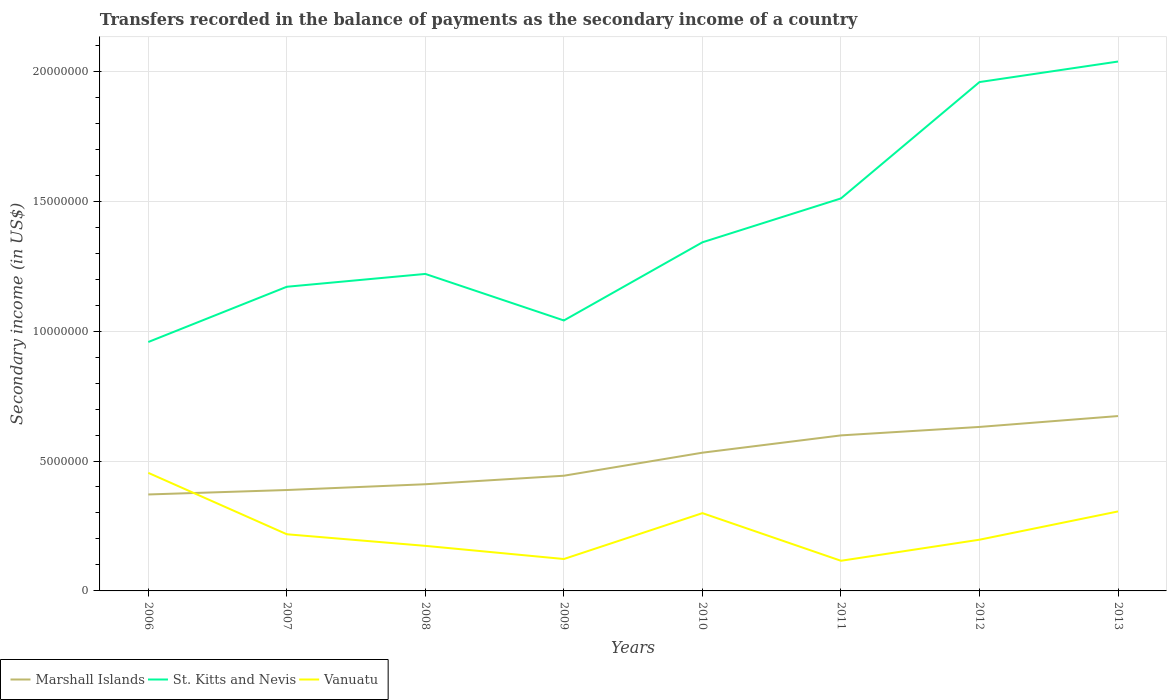How many different coloured lines are there?
Keep it short and to the point. 3. Is the number of lines equal to the number of legend labels?
Offer a terse response. Yes. Across all years, what is the maximum secondary income of in Vanuatu?
Your answer should be very brief. 1.16e+06. In which year was the secondary income of in Marshall Islands maximum?
Make the answer very short. 2006. What is the total secondary income of in Vanuatu in the graph?
Your answer should be very brief. -7.43e+05. What is the difference between the highest and the second highest secondary income of in St. Kitts and Nevis?
Ensure brevity in your answer.  1.08e+07. Is the secondary income of in Marshall Islands strictly greater than the secondary income of in St. Kitts and Nevis over the years?
Make the answer very short. Yes. How many lines are there?
Provide a short and direct response. 3. How many years are there in the graph?
Keep it short and to the point. 8. What is the difference between two consecutive major ticks on the Y-axis?
Give a very brief answer. 5.00e+06. Are the values on the major ticks of Y-axis written in scientific E-notation?
Your response must be concise. No. Does the graph contain grids?
Offer a terse response. Yes. How many legend labels are there?
Your answer should be very brief. 3. How are the legend labels stacked?
Offer a very short reply. Horizontal. What is the title of the graph?
Give a very brief answer. Transfers recorded in the balance of payments as the secondary income of a country. Does "Liechtenstein" appear as one of the legend labels in the graph?
Ensure brevity in your answer.  No. What is the label or title of the Y-axis?
Give a very brief answer. Secondary income (in US$). What is the Secondary income (in US$) in Marshall Islands in 2006?
Offer a terse response. 3.71e+06. What is the Secondary income (in US$) of St. Kitts and Nevis in 2006?
Give a very brief answer. 9.58e+06. What is the Secondary income (in US$) in Vanuatu in 2006?
Keep it short and to the point. 4.54e+06. What is the Secondary income (in US$) of Marshall Islands in 2007?
Provide a succinct answer. 3.88e+06. What is the Secondary income (in US$) in St. Kitts and Nevis in 2007?
Give a very brief answer. 1.17e+07. What is the Secondary income (in US$) of Vanuatu in 2007?
Provide a short and direct response. 2.18e+06. What is the Secondary income (in US$) of Marshall Islands in 2008?
Your answer should be compact. 4.11e+06. What is the Secondary income (in US$) in St. Kitts and Nevis in 2008?
Provide a short and direct response. 1.22e+07. What is the Secondary income (in US$) of Vanuatu in 2008?
Your answer should be compact. 1.73e+06. What is the Secondary income (in US$) in Marshall Islands in 2009?
Provide a short and direct response. 4.43e+06. What is the Secondary income (in US$) of St. Kitts and Nevis in 2009?
Your answer should be compact. 1.04e+07. What is the Secondary income (in US$) in Vanuatu in 2009?
Give a very brief answer. 1.23e+06. What is the Secondary income (in US$) in Marshall Islands in 2010?
Provide a short and direct response. 5.32e+06. What is the Secondary income (in US$) in St. Kitts and Nevis in 2010?
Make the answer very short. 1.34e+07. What is the Secondary income (in US$) in Vanuatu in 2010?
Your answer should be compact. 2.99e+06. What is the Secondary income (in US$) in Marshall Islands in 2011?
Offer a terse response. 5.99e+06. What is the Secondary income (in US$) of St. Kitts and Nevis in 2011?
Keep it short and to the point. 1.51e+07. What is the Secondary income (in US$) in Vanuatu in 2011?
Provide a succinct answer. 1.16e+06. What is the Secondary income (in US$) in Marshall Islands in 2012?
Offer a very short reply. 6.31e+06. What is the Secondary income (in US$) of St. Kitts and Nevis in 2012?
Keep it short and to the point. 1.96e+07. What is the Secondary income (in US$) of Vanuatu in 2012?
Offer a terse response. 1.97e+06. What is the Secondary income (in US$) of Marshall Islands in 2013?
Give a very brief answer. 6.73e+06. What is the Secondary income (in US$) of St. Kitts and Nevis in 2013?
Keep it short and to the point. 2.04e+07. What is the Secondary income (in US$) of Vanuatu in 2013?
Offer a very short reply. 3.06e+06. Across all years, what is the maximum Secondary income (in US$) in Marshall Islands?
Give a very brief answer. 6.73e+06. Across all years, what is the maximum Secondary income (in US$) of St. Kitts and Nevis?
Your response must be concise. 2.04e+07. Across all years, what is the maximum Secondary income (in US$) of Vanuatu?
Offer a terse response. 4.54e+06. Across all years, what is the minimum Secondary income (in US$) in Marshall Islands?
Your response must be concise. 3.71e+06. Across all years, what is the minimum Secondary income (in US$) in St. Kitts and Nevis?
Offer a very short reply. 9.58e+06. Across all years, what is the minimum Secondary income (in US$) of Vanuatu?
Provide a short and direct response. 1.16e+06. What is the total Secondary income (in US$) of Marshall Islands in the graph?
Make the answer very short. 4.05e+07. What is the total Secondary income (in US$) in St. Kitts and Nevis in the graph?
Your answer should be compact. 1.12e+08. What is the total Secondary income (in US$) of Vanuatu in the graph?
Ensure brevity in your answer.  1.89e+07. What is the difference between the Secondary income (in US$) of Marshall Islands in 2006 and that in 2007?
Your answer should be compact. -1.71e+05. What is the difference between the Secondary income (in US$) of St. Kitts and Nevis in 2006 and that in 2007?
Your answer should be compact. -2.13e+06. What is the difference between the Secondary income (in US$) of Vanuatu in 2006 and that in 2007?
Make the answer very short. 2.36e+06. What is the difference between the Secondary income (in US$) of Marshall Islands in 2006 and that in 2008?
Make the answer very short. -3.94e+05. What is the difference between the Secondary income (in US$) in St. Kitts and Nevis in 2006 and that in 2008?
Your answer should be compact. -2.62e+06. What is the difference between the Secondary income (in US$) in Vanuatu in 2006 and that in 2008?
Ensure brevity in your answer.  2.81e+06. What is the difference between the Secondary income (in US$) in Marshall Islands in 2006 and that in 2009?
Make the answer very short. -7.22e+05. What is the difference between the Secondary income (in US$) of St. Kitts and Nevis in 2006 and that in 2009?
Offer a very short reply. -8.29e+05. What is the difference between the Secondary income (in US$) of Vanuatu in 2006 and that in 2009?
Provide a succinct answer. 3.32e+06. What is the difference between the Secondary income (in US$) in Marshall Islands in 2006 and that in 2010?
Your answer should be compact. -1.61e+06. What is the difference between the Secondary income (in US$) in St. Kitts and Nevis in 2006 and that in 2010?
Make the answer very short. -3.84e+06. What is the difference between the Secondary income (in US$) of Vanuatu in 2006 and that in 2010?
Your answer should be very brief. 1.55e+06. What is the difference between the Secondary income (in US$) in Marshall Islands in 2006 and that in 2011?
Keep it short and to the point. -2.27e+06. What is the difference between the Secondary income (in US$) in St. Kitts and Nevis in 2006 and that in 2011?
Keep it short and to the point. -5.53e+06. What is the difference between the Secondary income (in US$) of Vanuatu in 2006 and that in 2011?
Your answer should be very brief. 3.38e+06. What is the difference between the Secondary income (in US$) of Marshall Islands in 2006 and that in 2012?
Provide a succinct answer. -2.60e+06. What is the difference between the Secondary income (in US$) in St. Kitts and Nevis in 2006 and that in 2012?
Your answer should be compact. -1.00e+07. What is the difference between the Secondary income (in US$) in Vanuatu in 2006 and that in 2012?
Your answer should be compact. 2.57e+06. What is the difference between the Secondary income (in US$) of Marshall Islands in 2006 and that in 2013?
Provide a succinct answer. -3.02e+06. What is the difference between the Secondary income (in US$) of St. Kitts and Nevis in 2006 and that in 2013?
Your answer should be compact. -1.08e+07. What is the difference between the Secondary income (in US$) of Vanuatu in 2006 and that in 2013?
Ensure brevity in your answer.  1.48e+06. What is the difference between the Secondary income (in US$) in Marshall Islands in 2007 and that in 2008?
Offer a terse response. -2.22e+05. What is the difference between the Secondary income (in US$) in St. Kitts and Nevis in 2007 and that in 2008?
Offer a terse response. -4.94e+05. What is the difference between the Secondary income (in US$) in Vanuatu in 2007 and that in 2008?
Your answer should be very brief. 4.47e+05. What is the difference between the Secondary income (in US$) of Marshall Islands in 2007 and that in 2009?
Offer a terse response. -5.51e+05. What is the difference between the Secondary income (in US$) of St. Kitts and Nevis in 2007 and that in 2009?
Your answer should be compact. 1.30e+06. What is the difference between the Secondary income (in US$) in Vanuatu in 2007 and that in 2009?
Give a very brief answer. 9.52e+05. What is the difference between the Secondary income (in US$) of Marshall Islands in 2007 and that in 2010?
Offer a terse response. -1.44e+06. What is the difference between the Secondary income (in US$) in St. Kitts and Nevis in 2007 and that in 2010?
Your answer should be very brief. -1.71e+06. What is the difference between the Secondary income (in US$) in Vanuatu in 2007 and that in 2010?
Offer a terse response. -8.13e+05. What is the difference between the Secondary income (in US$) in Marshall Islands in 2007 and that in 2011?
Your response must be concise. -2.10e+06. What is the difference between the Secondary income (in US$) in St. Kitts and Nevis in 2007 and that in 2011?
Give a very brief answer. -3.40e+06. What is the difference between the Secondary income (in US$) of Vanuatu in 2007 and that in 2011?
Your response must be concise. 1.02e+06. What is the difference between the Secondary income (in US$) of Marshall Islands in 2007 and that in 2012?
Ensure brevity in your answer.  -2.43e+06. What is the difference between the Secondary income (in US$) of St. Kitts and Nevis in 2007 and that in 2012?
Provide a succinct answer. -7.88e+06. What is the difference between the Secondary income (in US$) of Vanuatu in 2007 and that in 2012?
Keep it short and to the point. 2.10e+05. What is the difference between the Secondary income (in US$) in Marshall Islands in 2007 and that in 2013?
Provide a succinct answer. -2.85e+06. What is the difference between the Secondary income (in US$) of St. Kitts and Nevis in 2007 and that in 2013?
Offer a very short reply. -8.67e+06. What is the difference between the Secondary income (in US$) in Vanuatu in 2007 and that in 2013?
Provide a succinct answer. -8.79e+05. What is the difference between the Secondary income (in US$) of Marshall Islands in 2008 and that in 2009?
Give a very brief answer. -3.28e+05. What is the difference between the Secondary income (in US$) in St. Kitts and Nevis in 2008 and that in 2009?
Keep it short and to the point. 1.79e+06. What is the difference between the Secondary income (in US$) in Vanuatu in 2008 and that in 2009?
Give a very brief answer. 5.06e+05. What is the difference between the Secondary income (in US$) of Marshall Islands in 2008 and that in 2010?
Offer a terse response. -1.21e+06. What is the difference between the Secondary income (in US$) of St. Kitts and Nevis in 2008 and that in 2010?
Provide a short and direct response. -1.22e+06. What is the difference between the Secondary income (in US$) of Vanuatu in 2008 and that in 2010?
Your answer should be very brief. -1.26e+06. What is the difference between the Secondary income (in US$) of Marshall Islands in 2008 and that in 2011?
Your response must be concise. -1.88e+06. What is the difference between the Secondary income (in US$) in St. Kitts and Nevis in 2008 and that in 2011?
Ensure brevity in your answer.  -2.91e+06. What is the difference between the Secondary income (in US$) in Vanuatu in 2008 and that in 2011?
Offer a very short reply. 5.74e+05. What is the difference between the Secondary income (in US$) in Marshall Islands in 2008 and that in 2012?
Offer a very short reply. -2.21e+06. What is the difference between the Secondary income (in US$) in St. Kitts and Nevis in 2008 and that in 2012?
Provide a short and direct response. -7.38e+06. What is the difference between the Secondary income (in US$) in Vanuatu in 2008 and that in 2012?
Provide a short and direct response. -2.37e+05. What is the difference between the Secondary income (in US$) of Marshall Islands in 2008 and that in 2013?
Offer a terse response. -2.62e+06. What is the difference between the Secondary income (in US$) of St. Kitts and Nevis in 2008 and that in 2013?
Offer a very short reply. -8.17e+06. What is the difference between the Secondary income (in US$) of Vanuatu in 2008 and that in 2013?
Provide a succinct answer. -1.33e+06. What is the difference between the Secondary income (in US$) of Marshall Islands in 2009 and that in 2010?
Offer a terse response. -8.86e+05. What is the difference between the Secondary income (in US$) in St. Kitts and Nevis in 2009 and that in 2010?
Provide a short and direct response. -3.01e+06. What is the difference between the Secondary income (in US$) of Vanuatu in 2009 and that in 2010?
Your response must be concise. -1.77e+06. What is the difference between the Secondary income (in US$) of Marshall Islands in 2009 and that in 2011?
Make the answer very short. -1.55e+06. What is the difference between the Secondary income (in US$) of St. Kitts and Nevis in 2009 and that in 2011?
Offer a terse response. -4.70e+06. What is the difference between the Secondary income (in US$) in Vanuatu in 2009 and that in 2011?
Provide a succinct answer. 6.81e+04. What is the difference between the Secondary income (in US$) of Marshall Islands in 2009 and that in 2012?
Make the answer very short. -1.88e+06. What is the difference between the Secondary income (in US$) in St. Kitts and Nevis in 2009 and that in 2012?
Make the answer very short. -9.18e+06. What is the difference between the Secondary income (in US$) in Vanuatu in 2009 and that in 2012?
Provide a short and direct response. -7.43e+05. What is the difference between the Secondary income (in US$) in Marshall Islands in 2009 and that in 2013?
Ensure brevity in your answer.  -2.30e+06. What is the difference between the Secondary income (in US$) in St. Kitts and Nevis in 2009 and that in 2013?
Make the answer very short. -9.97e+06. What is the difference between the Secondary income (in US$) of Vanuatu in 2009 and that in 2013?
Offer a very short reply. -1.83e+06. What is the difference between the Secondary income (in US$) in Marshall Islands in 2010 and that in 2011?
Your answer should be compact. -6.65e+05. What is the difference between the Secondary income (in US$) in St. Kitts and Nevis in 2010 and that in 2011?
Offer a very short reply. -1.69e+06. What is the difference between the Secondary income (in US$) in Vanuatu in 2010 and that in 2011?
Offer a terse response. 1.83e+06. What is the difference between the Secondary income (in US$) of Marshall Islands in 2010 and that in 2012?
Your answer should be very brief. -9.91e+05. What is the difference between the Secondary income (in US$) of St. Kitts and Nevis in 2010 and that in 2012?
Your response must be concise. -6.17e+06. What is the difference between the Secondary income (in US$) in Vanuatu in 2010 and that in 2012?
Your answer should be compact. 1.02e+06. What is the difference between the Secondary income (in US$) of Marshall Islands in 2010 and that in 2013?
Provide a succinct answer. -1.41e+06. What is the difference between the Secondary income (in US$) in St. Kitts and Nevis in 2010 and that in 2013?
Your answer should be very brief. -6.96e+06. What is the difference between the Secondary income (in US$) in Vanuatu in 2010 and that in 2013?
Your answer should be compact. -6.57e+04. What is the difference between the Secondary income (in US$) of Marshall Islands in 2011 and that in 2012?
Ensure brevity in your answer.  -3.26e+05. What is the difference between the Secondary income (in US$) of St. Kitts and Nevis in 2011 and that in 2012?
Give a very brief answer. -4.48e+06. What is the difference between the Secondary income (in US$) of Vanuatu in 2011 and that in 2012?
Ensure brevity in your answer.  -8.11e+05. What is the difference between the Secondary income (in US$) of Marshall Islands in 2011 and that in 2013?
Your response must be concise. -7.44e+05. What is the difference between the Secondary income (in US$) in St. Kitts and Nevis in 2011 and that in 2013?
Your answer should be compact. -5.27e+06. What is the difference between the Secondary income (in US$) of Vanuatu in 2011 and that in 2013?
Provide a short and direct response. -1.90e+06. What is the difference between the Secondary income (in US$) of Marshall Islands in 2012 and that in 2013?
Provide a succinct answer. -4.19e+05. What is the difference between the Secondary income (in US$) of St. Kitts and Nevis in 2012 and that in 2013?
Give a very brief answer. -7.90e+05. What is the difference between the Secondary income (in US$) of Vanuatu in 2012 and that in 2013?
Keep it short and to the point. -1.09e+06. What is the difference between the Secondary income (in US$) of Marshall Islands in 2006 and the Secondary income (in US$) of St. Kitts and Nevis in 2007?
Your answer should be very brief. -7.99e+06. What is the difference between the Secondary income (in US$) of Marshall Islands in 2006 and the Secondary income (in US$) of Vanuatu in 2007?
Your answer should be very brief. 1.53e+06. What is the difference between the Secondary income (in US$) of St. Kitts and Nevis in 2006 and the Secondary income (in US$) of Vanuatu in 2007?
Offer a very short reply. 7.40e+06. What is the difference between the Secondary income (in US$) of Marshall Islands in 2006 and the Secondary income (in US$) of St. Kitts and Nevis in 2008?
Ensure brevity in your answer.  -8.49e+06. What is the difference between the Secondary income (in US$) in Marshall Islands in 2006 and the Secondary income (in US$) in Vanuatu in 2008?
Ensure brevity in your answer.  1.98e+06. What is the difference between the Secondary income (in US$) of St. Kitts and Nevis in 2006 and the Secondary income (in US$) of Vanuatu in 2008?
Keep it short and to the point. 7.85e+06. What is the difference between the Secondary income (in US$) in Marshall Islands in 2006 and the Secondary income (in US$) in St. Kitts and Nevis in 2009?
Give a very brief answer. -6.70e+06. What is the difference between the Secondary income (in US$) in Marshall Islands in 2006 and the Secondary income (in US$) in Vanuatu in 2009?
Provide a succinct answer. 2.48e+06. What is the difference between the Secondary income (in US$) in St. Kitts and Nevis in 2006 and the Secondary income (in US$) in Vanuatu in 2009?
Your answer should be very brief. 8.35e+06. What is the difference between the Secondary income (in US$) in Marshall Islands in 2006 and the Secondary income (in US$) in St. Kitts and Nevis in 2010?
Your answer should be very brief. -9.71e+06. What is the difference between the Secondary income (in US$) of Marshall Islands in 2006 and the Secondary income (in US$) of Vanuatu in 2010?
Provide a short and direct response. 7.18e+05. What is the difference between the Secondary income (in US$) of St. Kitts and Nevis in 2006 and the Secondary income (in US$) of Vanuatu in 2010?
Make the answer very short. 6.59e+06. What is the difference between the Secondary income (in US$) of Marshall Islands in 2006 and the Secondary income (in US$) of St. Kitts and Nevis in 2011?
Provide a short and direct response. -1.14e+07. What is the difference between the Secondary income (in US$) of Marshall Islands in 2006 and the Secondary income (in US$) of Vanuatu in 2011?
Your answer should be very brief. 2.55e+06. What is the difference between the Secondary income (in US$) of St. Kitts and Nevis in 2006 and the Secondary income (in US$) of Vanuatu in 2011?
Provide a succinct answer. 8.42e+06. What is the difference between the Secondary income (in US$) in Marshall Islands in 2006 and the Secondary income (in US$) in St. Kitts and Nevis in 2012?
Provide a succinct answer. -1.59e+07. What is the difference between the Secondary income (in US$) of Marshall Islands in 2006 and the Secondary income (in US$) of Vanuatu in 2012?
Keep it short and to the point. 1.74e+06. What is the difference between the Secondary income (in US$) of St. Kitts and Nevis in 2006 and the Secondary income (in US$) of Vanuatu in 2012?
Provide a succinct answer. 7.61e+06. What is the difference between the Secondary income (in US$) of Marshall Islands in 2006 and the Secondary income (in US$) of St. Kitts and Nevis in 2013?
Offer a very short reply. -1.67e+07. What is the difference between the Secondary income (in US$) of Marshall Islands in 2006 and the Secondary income (in US$) of Vanuatu in 2013?
Your answer should be compact. 6.53e+05. What is the difference between the Secondary income (in US$) in St. Kitts and Nevis in 2006 and the Secondary income (in US$) in Vanuatu in 2013?
Your answer should be very brief. 6.52e+06. What is the difference between the Secondary income (in US$) of Marshall Islands in 2007 and the Secondary income (in US$) of St. Kitts and Nevis in 2008?
Offer a very short reply. -8.32e+06. What is the difference between the Secondary income (in US$) in Marshall Islands in 2007 and the Secondary income (in US$) in Vanuatu in 2008?
Give a very brief answer. 2.15e+06. What is the difference between the Secondary income (in US$) in St. Kitts and Nevis in 2007 and the Secondary income (in US$) in Vanuatu in 2008?
Keep it short and to the point. 9.97e+06. What is the difference between the Secondary income (in US$) in Marshall Islands in 2007 and the Secondary income (in US$) in St. Kitts and Nevis in 2009?
Your answer should be compact. -6.53e+06. What is the difference between the Secondary income (in US$) in Marshall Islands in 2007 and the Secondary income (in US$) in Vanuatu in 2009?
Offer a very short reply. 2.65e+06. What is the difference between the Secondary income (in US$) in St. Kitts and Nevis in 2007 and the Secondary income (in US$) in Vanuatu in 2009?
Offer a terse response. 1.05e+07. What is the difference between the Secondary income (in US$) of Marshall Islands in 2007 and the Secondary income (in US$) of St. Kitts and Nevis in 2010?
Provide a succinct answer. -9.53e+06. What is the difference between the Secondary income (in US$) in Marshall Islands in 2007 and the Secondary income (in US$) in Vanuatu in 2010?
Provide a short and direct response. 8.90e+05. What is the difference between the Secondary income (in US$) in St. Kitts and Nevis in 2007 and the Secondary income (in US$) in Vanuatu in 2010?
Provide a short and direct response. 8.71e+06. What is the difference between the Secondary income (in US$) of Marshall Islands in 2007 and the Secondary income (in US$) of St. Kitts and Nevis in 2011?
Offer a very short reply. -1.12e+07. What is the difference between the Secondary income (in US$) in Marshall Islands in 2007 and the Secondary income (in US$) in Vanuatu in 2011?
Make the answer very short. 2.72e+06. What is the difference between the Secondary income (in US$) of St. Kitts and Nevis in 2007 and the Secondary income (in US$) of Vanuatu in 2011?
Provide a succinct answer. 1.05e+07. What is the difference between the Secondary income (in US$) in Marshall Islands in 2007 and the Secondary income (in US$) in St. Kitts and Nevis in 2012?
Provide a succinct answer. -1.57e+07. What is the difference between the Secondary income (in US$) of Marshall Islands in 2007 and the Secondary income (in US$) of Vanuatu in 2012?
Your response must be concise. 1.91e+06. What is the difference between the Secondary income (in US$) of St. Kitts and Nevis in 2007 and the Secondary income (in US$) of Vanuatu in 2012?
Your answer should be very brief. 9.74e+06. What is the difference between the Secondary income (in US$) of Marshall Islands in 2007 and the Secondary income (in US$) of St. Kitts and Nevis in 2013?
Keep it short and to the point. -1.65e+07. What is the difference between the Secondary income (in US$) of Marshall Islands in 2007 and the Secondary income (in US$) of Vanuatu in 2013?
Make the answer very short. 8.24e+05. What is the difference between the Secondary income (in US$) in St. Kitts and Nevis in 2007 and the Secondary income (in US$) in Vanuatu in 2013?
Offer a very short reply. 8.65e+06. What is the difference between the Secondary income (in US$) in Marshall Islands in 2008 and the Secondary income (in US$) in St. Kitts and Nevis in 2009?
Ensure brevity in your answer.  -6.30e+06. What is the difference between the Secondary income (in US$) of Marshall Islands in 2008 and the Secondary income (in US$) of Vanuatu in 2009?
Your answer should be very brief. 2.88e+06. What is the difference between the Secondary income (in US$) of St. Kitts and Nevis in 2008 and the Secondary income (in US$) of Vanuatu in 2009?
Your answer should be compact. 1.10e+07. What is the difference between the Secondary income (in US$) of Marshall Islands in 2008 and the Secondary income (in US$) of St. Kitts and Nevis in 2010?
Provide a short and direct response. -9.31e+06. What is the difference between the Secondary income (in US$) of Marshall Islands in 2008 and the Secondary income (in US$) of Vanuatu in 2010?
Your response must be concise. 1.11e+06. What is the difference between the Secondary income (in US$) in St. Kitts and Nevis in 2008 and the Secondary income (in US$) in Vanuatu in 2010?
Keep it short and to the point. 9.21e+06. What is the difference between the Secondary income (in US$) in Marshall Islands in 2008 and the Secondary income (in US$) in St. Kitts and Nevis in 2011?
Offer a terse response. -1.10e+07. What is the difference between the Secondary income (in US$) of Marshall Islands in 2008 and the Secondary income (in US$) of Vanuatu in 2011?
Your answer should be compact. 2.95e+06. What is the difference between the Secondary income (in US$) in St. Kitts and Nevis in 2008 and the Secondary income (in US$) in Vanuatu in 2011?
Ensure brevity in your answer.  1.10e+07. What is the difference between the Secondary income (in US$) in Marshall Islands in 2008 and the Secondary income (in US$) in St. Kitts and Nevis in 2012?
Your response must be concise. -1.55e+07. What is the difference between the Secondary income (in US$) in Marshall Islands in 2008 and the Secondary income (in US$) in Vanuatu in 2012?
Provide a short and direct response. 2.13e+06. What is the difference between the Secondary income (in US$) of St. Kitts and Nevis in 2008 and the Secondary income (in US$) of Vanuatu in 2012?
Keep it short and to the point. 1.02e+07. What is the difference between the Secondary income (in US$) of Marshall Islands in 2008 and the Secondary income (in US$) of St. Kitts and Nevis in 2013?
Your answer should be very brief. -1.63e+07. What is the difference between the Secondary income (in US$) of Marshall Islands in 2008 and the Secondary income (in US$) of Vanuatu in 2013?
Your response must be concise. 1.05e+06. What is the difference between the Secondary income (in US$) of St. Kitts and Nevis in 2008 and the Secondary income (in US$) of Vanuatu in 2013?
Provide a short and direct response. 9.14e+06. What is the difference between the Secondary income (in US$) in Marshall Islands in 2009 and the Secondary income (in US$) in St. Kitts and Nevis in 2010?
Your answer should be compact. -8.98e+06. What is the difference between the Secondary income (in US$) of Marshall Islands in 2009 and the Secondary income (in US$) of Vanuatu in 2010?
Keep it short and to the point. 1.44e+06. What is the difference between the Secondary income (in US$) in St. Kitts and Nevis in 2009 and the Secondary income (in US$) in Vanuatu in 2010?
Your answer should be compact. 7.42e+06. What is the difference between the Secondary income (in US$) of Marshall Islands in 2009 and the Secondary income (in US$) of St. Kitts and Nevis in 2011?
Provide a succinct answer. -1.07e+07. What is the difference between the Secondary income (in US$) in Marshall Islands in 2009 and the Secondary income (in US$) in Vanuatu in 2011?
Ensure brevity in your answer.  3.27e+06. What is the difference between the Secondary income (in US$) of St. Kitts and Nevis in 2009 and the Secondary income (in US$) of Vanuatu in 2011?
Offer a very short reply. 9.25e+06. What is the difference between the Secondary income (in US$) of Marshall Islands in 2009 and the Secondary income (in US$) of St. Kitts and Nevis in 2012?
Offer a very short reply. -1.52e+07. What is the difference between the Secondary income (in US$) in Marshall Islands in 2009 and the Secondary income (in US$) in Vanuatu in 2012?
Your answer should be compact. 2.46e+06. What is the difference between the Secondary income (in US$) of St. Kitts and Nevis in 2009 and the Secondary income (in US$) of Vanuatu in 2012?
Keep it short and to the point. 8.44e+06. What is the difference between the Secondary income (in US$) of Marshall Islands in 2009 and the Secondary income (in US$) of St. Kitts and Nevis in 2013?
Offer a very short reply. -1.59e+07. What is the difference between the Secondary income (in US$) of Marshall Islands in 2009 and the Secondary income (in US$) of Vanuatu in 2013?
Offer a very short reply. 1.37e+06. What is the difference between the Secondary income (in US$) in St. Kitts and Nevis in 2009 and the Secondary income (in US$) in Vanuatu in 2013?
Your answer should be very brief. 7.35e+06. What is the difference between the Secondary income (in US$) of Marshall Islands in 2010 and the Secondary income (in US$) of St. Kitts and Nevis in 2011?
Make the answer very short. -9.79e+06. What is the difference between the Secondary income (in US$) of Marshall Islands in 2010 and the Secondary income (in US$) of Vanuatu in 2011?
Make the answer very short. 4.16e+06. What is the difference between the Secondary income (in US$) of St. Kitts and Nevis in 2010 and the Secondary income (in US$) of Vanuatu in 2011?
Your answer should be compact. 1.23e+07. What is the difference between the Secondary income (in US$) of Marshall Islands in 2010 and the Secondary income (in US$) of St. Kitts and Nevis in 2012?
Offer a very short reply. -1.43e+07. What is the difference between the Secondary income (in US$) of Marshall Islands in 2010 and the Secondary income (in US$) of Vanuatu in 2012?
Make the answer very short. 3.35e+06. What is the difference between the Secondary income (in US$) of St. Kitts and Nevis in 2010 and the Secondary income (in US$) of Vanuatu in 2012?
Make the answer very short. 1.14e+07. What is the difference between the Secondary income (in US$) in Marshall Islands in 2010 and the Secondary income (in US$) in St. Kitts and Nevis in 2013?
Provide a succinct answer. -1.51e+07. What is the difference between the Secondary income (in US$) of Marshall Islands in 2010 and the Secondary income (in US$) of Vanuatu in 2013?
Your answer should be very brief. 2.26e+06. What is the difference between the Secondary income (in US$) in St. Kitts and Nevis in 2010 and the Secondary income (in US$) in Vanuatu in 2013?
Your answer should be very brief. 1.04e+07. What is the difference between the Secondary income (in US$) of Marshall Islands in 2011 and the Secondary income (in US$) of St. Kitts and Nevis in 2012?
Provide a succinct answer. -1.36e+07. What is the difference between the Secondary income (in US$) of Marshall Islands in 2011 and the Secondary income (in US$) of Vanuatu in 2012?
Your answer should be very brief. 4.01e+06. What is the difference between the Secondary income (in US$) in St. Kitts and Nevis in 2011 and the Secondary income (in US$) in Vanuatu in 2012?
Your response must be concise. 1.31e+07. What is the difference between the Secondary income (in US$) of Marshall Islands in 2011 and the Secondary income (in US$) of St. Kitts and Nevis in 2013?
Provide a succinct answer. -1.44e+07. What is the difference between the Secondary income (in US$) of Marshall Islands in 2011 and the Secondary income (in US$) of Vanuatu in 2013?
Offer a terse response. 2.93e+06. What is the difference between the Secondary income (in US$) in St. Kitts and Nevis in 2011 and the Secondary income (in US$) in Vanuatu in 2013?
Your answer should be very brief. 1.20e+07. What is the difference between the Secondary income (in US$) of Marshall Islands in 2012 and the Secondary income (in US$) of St. Kitts and Nevis in 2013?
Provide a succinct answer. -1.41e+07. What is the difference between the Secondary income (in US$) of Marshall Islands in 2012 and the Secondary income (in US$) of Vanuatu in 2013?
Offer a terse response. 3.25e+06. What is the difference between the Secondary income (in US$) in St. Kitts and Nevis in 2012 and the Secondary income (in US$) in Vanuatu in 2013?
Provide a succinct answer. 1.65e+07. What is the average Secondary income (in US$) of Marshall Islands per year?
Keep it short and to the point. 5.06e+06. What is the average Secondary income (in US$) of St. Kitts and Nevis per year?
Make the answer very short. 1.40e+07. What is the average Secondary income (in US$) in Vanuatu per year?
Your response must be concise. 2.36e+06. In the year 2006, what is the difference between the Secondary income (in US$) in Marshall Islands and Secondary income (in US$) in St. Kitts and Nevis?
Make the answer very short. -5.87e+06. In the year 2006, what is the difference between the Secondary income (in US$) of Marshall Islands and Secondary income (in US$) of Vanuatu?
Your answer should be very brief. -8.32e+05. In the year 2006, what is the difference between the Secondary income (in US$) in St. Kitts and Nevis and Secondary income (in US$) in Vanuatu?
Give a very brief answer. 5.04e+06. In the year 2007, what is the difference between the Secondary income (in US$) in Marshall Islands and Secondary income (in US$) in St. Kitts and Nevis?
Give a very brief answer. -7.82e+06. In the year 2007, what is the difference between the Secondary income (in US$) of Marshall Islands and Secondary income (in US$) of Vanuatu?
Make the answer very short. 1.70e+06. In the year 2007, what is the difference between the Secondary income (in US$) of St. Kitts and Nevis and Secondary income (in US$) of Vanuatu?
Ensure brevity in your answer.  9.53e+06. In the year 2008, what is the difference between the Secondary income (in US$) in Marshall Islands and Secondary income (in US$) in St. Kitts and Nevis?
Your response must be concise. -8.09e+06. In the year 2008, what is the difference between the Secondary income (in US$) in Marshall Islands and Secondary income (in US$) in Vanuatu?
Provide a succinct answer. 2.37e+06. In the year 2008, what is the difference between the Secondary income (in US$) of St. Kitts and Nevis and Secondary income (in US$) of Vanuatu?
Keep it short and to the point. 1.05e+07. In the year 2009, what is the difference between the Secondary income (in US$) of Marshall Islands and Secondary income (in US$) of St. Kitts and Nevis?
Offer a very short reply. -5.98e+06. In the year 2009, what is the difference between the Secondary income (in US$) of Marshall Islands and Secondary income (in US$) of Vanuatu?
Your answer should be compact. 3.21e+06. In the year 2009, what is the difference between the Secondary income (in US$) of St. Kitts and Nevis and Secondary income (in US$) of Vanuatu?
Your response must be concise. 9.18e+06. In the year 2010, what is the difference between the Secondary income (in US$) in Marshall Islands and Secondary income (in US$) in St. Kitts and Nevis?
Offer a terse response. -8.10e+06. In the year 2010, what is the difference between the Secondary income (in US$) in Marshall Islands and Secondary income (in US$) in Vanuatu?
Your response must be concise. 2.33e+06. In the year 2010, what is the difference between the Secondary income (in US$) in St. Kitts and Nevis and Secondary income (in US$) in Vanuatu?
Provide a short and direct response. 1.04e+07. In the year 2011, what is the difference between the Secondary income (in US$) of Marshall Islands and Secondary income (in US$) of St. Kitts and Nevis?
Give a very brief answer. -9.12e+06. In the year 2011, what is the difference between the Secondary income (in US$) of Marshall Islands and Secondary income (in US$) of Vanuatu?
Ensure brevity in your answer.  4.83e+06. In the year 2011, what is the difference between the Secondary income (in US$) in St. Kitts and Nevis and Secondary income (in US$) in Vanuatu?
Keep it short and to the point. 1.39e+07. In the year 2012, what is the difference between the Secondary income (in US$) in Marshall Islands and Secondary income (in US$) in St. Kitts and Nevis?
Make the answer very short. -1.33e+07. In the year 2012, what is the difference between the Secondary income (in US$) of Marshall Islands and Secondary income (in US$) of Vanuatu?
Your answer should be compact. 4.34e+06. In the year 2012, what is the difference between the Secondary income (in US$) in St. Kitts and Nevis and Secondary income (in US$) in Vanuatu?
Make the answer very short. 1.76e+07. In the year 2013, what is the difference between the Secondary income (in US$) in Marshall Islands and Secondary income (in US$) in St. Kitts and Nevis?
Offer a very short reply. -1.36e+07. In the year 2013, what is the difference between the Secondary income (in US$) of Marshall Islands and Secondary income (in US$) of Vanuatu?
Offer a very short reply. 3.67e+06. In the year 2013, what is the difference between the Secondary income (in US$) in St. Kitts and Nevis and Secondary income (in US$) in Vanuatu?
Give a very brief answer. 1.73e+07. What is the ratio of the Secondary income (in US$) in Marshall Islands in 2006 to that in 2007?
Provide a short and direct response. 0.96. What is the ratio of the Secondary income (in US$) of St. Kitts and Nevis in 2006 to that in 2007?
Your response must be concise. 0.82. What is the ratio of the Secondary income (in US$) of Vanuatu in 2006 to that in 2007?
Your answer should be compact. 2.08. What is the ratio of the Secondary income (in US$) in Marshall Islands in 2006 to that in 2008?
Your response must be concise. 0.9. What is the ratio of the Secondary income (in US$) in St. Kitts and Nevis in 2006 to that in 2008?
Provide a succinct answer. 0.79. What is the ratio of the Secondary income (in US$) in Vanuatu in 2006 to that in 2008?
Keep it short and to the point. 2.62. What is the ratio of the Secondary income (in US$) of Marshall Islands in 2006 to that in 2009?
Your answer should be very brief. 0.84. What is the ratio of the Secondary income (in US$) of St. Kitts and Nevis in 2006 to that in 2009?
Provide a succinct answer. 0.92. What is the ratio of the Secondary income (in US$) in Vanuatu in 2006 to that in 2009?
Keep it short and to the point. 3.7. What is the ratio of the Secondary income (in US$) in Marshall Islands in 2006 to that in 2010?
Offer a terse response. 0.7. What is the ratio of the Secondary income (in US$) of St. Kitts and Nevis in 2006 to that in 2010?
Offer a terse response. 0.71. What is the ratio of the Secondary income (in US$) of Vanuatu in 2006 to that in 2010?
Your response must be concise. 1.52. What is the ratio of the Secondary income (in US$) of Marshall Islands in 2006 to that in 2011?
Give a very brief answer. 0.62. What is the ratio of the Secondary income (in US$) of St. Kitts and Nevis in 2006 to that in 2011?
Ensure brevity in your answer.  0.63. What is the ratio of the Secondary income (in US$) in Vanuatu in 2006 to that in 2011?
Keep it short and to the point. 3.92. What is the ratio of the Secondary income (in US$) of Marshall Islands in 2006 to that in 2012?
Your response must be concise. 0.59. What is the ratio of the Secondary income (in US$) in St. Kitts and Nevis in 2006 to that in 2012?
Provide a short and direct response. 0.49. What is the ratio of the Secondary income (in US$) in Vanuatu in 2006 to that in 2012?
Provide a short and direct response. 2.31. What is the ratio of the Secondary income (in US$) of Marshall Islands in 2006 to that in 2013?
Your answer should be very brief. 0.55. What is the ratio of the Secondary income (in US$) in St. Kitts and Nevis in 2006 to that in 2013?
Provide a short and direct response. 0.47. What is the ratio of the Secondary income (in US$) in Vanuatu in 2006 to that in 2013?
Your answer should be compact. 1.49. What is the ratio of the Secondary income (in US$) in Marshall Islands in 2007 to that in 2008?
Provide a short and direct response. 0.95. What is the ratio of the Secondary income (in US$) in St. Kitts and Nevis in 2007 to that in 2008?
Offer a terse response. 0.96. What is the ratio of the Secondary income (in US$) of Vanuatu in 2007 to that in 2008?
Keep it short and to the point. 1.26. What is the ratio of the Secondary income (in US$) of Marshall Islands in 2007 to that in 2009?
Your response must be concise. 0.88. What is the ratio of the Secondary income (in US$) in St. Kitts and Nevis in 2007 to that in 2009?
Make the answer very short. 1.12. What is the ratio of the Secondary income (in US$) of Vanuatu in 2007 to that in 2009?
Offer a very short reply. 1.78. What is the ratio of the Secondary income (in US$) of Marshall Islands in 2007 to that in 2010?
Provide a short and direct response. 0.73. What is the ratio of the Secondary income (in US$) of St. Kitts and Nevis in 2007 to that in 2010?
Offer a very short reply. 0.87. What is the ratio of the Secondary income (in US$) of Vanuatu in 2007 to that in 2010?
Provide a succinct answer. 0.73. What is the ratio of the Secondary income (in US$) of Marshall Islands in 2007 to that in 2011?
Ensure brevity in your answer.  0.65. What is the ratio of the Secondary income (in US$) in St. Kitts and Nevis in 2007 to that in 2011?
Ensure brevity in your answer.  0.77. What is the ratio of the Secondary income (in US$) of Vanuatu in 2007 to that in 2011?
Provide a succinct answer. 1.88. What is the ratio of the Secondary income (in US$) of Marshall Islands in 2007 to that in 2012?
Your response must be concise. 0.62. What is the ratio of the Secondary income (in US$) of St. Kitts and Nevis in 2007 to that in 2012?
Offer a very short reply. 0.6. What is the ratio of the Secondary income (in US$) of Vanuatu in 2007 to that in 2012?
Ensure brevity in your answer.  1.11. What is the ratio of the Secondary income (in US$) of Marshall Islands in 2007 to that in 2013?
Your answer should be very brief. 0.58. What is the ratio of the Secondary income (in US$) in St. Kitts and Nevis in 2007 to that in 2013?
Ensure brevity in your answer.  0.57. What is the ratio of the Secondary income (in US$) of Vanuatu in 2007 to that in 2013?
Offer a very short reply. 0.71. What is the ratio of the Secondary income (in US$) of Marshall Islands in 2008 to that in 2009?
Provide a short and direct response. 0.93. What is the ratio of the Secondary income (in US$) in St. Kitts and Nevis in 2008 to that in 2009?
Provide a short and direct response. 1.17. What is the ratio of the Secondary income (in US$) of Vanuatu in 2008 to that in 2009?
Make the answer very short. 1.41. What is the ratio of the Secondary income (in US$) of Marshall Islands in 2008 to that in 2010?
Your answer should be compact. 0.77. What is the ratio of the Secondary income (in US$) of St. Kitts and Nevis in 2008 to that in 2010?
Ensure brevity in your answer.  0.91. What is the ratio of the Secondary income (in US$) in Vanuatu in 2008 to that in 2010?
Provide a short and direct response. 0.58. What is the ratio of the Secondary income (in US$) of Marshall Islands in 2008 to that in 2011?
Offer a terse response. 0.69. What is the ratio of the Secondary income (in US$) in St. Kitts and Nevis in 2008 to that in 2011?
Offer a terse response. 0.81. What is the ratio of the Secondary income (in US$) of Vanuatu in 2008 to that in 2011?
Provide a short and direct response. 1.49. What is the ratio of the Secondary income (in US$) of Marshall Islands in 2008 to that in 2012?
Give a very brief answer. 0.65. What is the ratio of the Secondary income (in US$) of St. Kitts and Nevis in 2008 to that in 2012?
Your answer should be compact. 0.62. What is the ratio of the Secondary income (in US$) of Vanuatu in 2008 to that in 2012?
Provide a succinct answer. 0.88. What is the ratio of the Secondary income (in US$) of Marshall Islands in 2008 to that in 2013?
Offer a terse response. 0.61. What is the ratio of the Secondary income (in US$) of St. Kitts and Nevis in 2008 to that in 2013?
Give a very brief answer. 0.6. What is the ratio of the Secondary income (in US$) of Vanuatu in 2008 to that in 2013?
Provide a succinct answer. 0.57. What is the ratio of the Secondary income (in US$) in Marshall Islands in 2009 to that in 2010?
Offer a terse response. 0.83. What is the ratio of the Secondary income (in US$) of St. Kitts and Nevis in 2009 to that in 2010?
Your response must be concise. 0.78. What is the ratio of the Secondary income (in US$) of Vanuatu in 2009 to that in 2010?
Make the answer very short. 0.41. What is the ratio of the Secondary income (in US$) of Marshall Islands in 2009 to that in 2011?
Offer a terse response. 0.74. What is the ratio of the Secondary income (in US$) in St. Kitts and Nevis in 2009 to that in 2011?
Make the answer very short. 0.69. What is the ratio of the Secondary income (in US$) in Vanuatu in 2009 to that in 2011?
Ensure brevity in your answer.  1.06. What is the ratio of the Secondary income (in US$) in Marshall Islands in 2009 to that in 2012?
Give a very brief answer. 0.7. What is the ratio of the Secondary income (in US$) of St. Kitts and Nevis in 2009 to that in 2012?
Your response must be concise. 0.53. What is the ratio of the Secondary income (in US$) of Vanuatu in 2009 to that in 2012?
Ensure brevity in your answer.  0.62. What is the ratio of the Secondary income (in US$) in Marshall Islands in 2009 to that in 2013?
Offer a very short reply. 0.66. What is the ratio of the Secondary income (in US$) of St. Kitts and Nevis in 2009 to that in 2013?
Provide a short and direct response. 0.51. What is the ratio of the Secondary income (in US$) in Vanuatu in 2009 to that in 2013?
Offer a very short reply. 0.4. What is the ratio of the Secondary income (in US$) in Marshall Islands in 2010 to that in 2011?
Make the answer very short. 0.89. What is the ratio of the Secondary income (in US$) of St. Kitts and Nevis in 2010 to that in 2011?
Provide a succinct answer. 0.89. What is the ratio of the Secondary income (in US$) in Vanuatu in 2010 to that in 2011?
Keep it short and to the point. 2.58. What is the ratio of the Secondary income (in US$) in Marshall Islands in 2010 to that in 2012?
Provide a short and direct response. 0.84. What is the ratio of the Secondary income (in US$) of St. Kitts and Nevis in 2010 to that in 2012?
Your response must be concise. 0.69. What is the ratio of the Secondary income (in US$) in Vanuatu in 2010 to that in 2012?
Provide a succinct answer. 1.52. What is the ratio of the Secondary income (in US$) of Marshall Islands in 2010 to that in 2013?
Provide a short and direct response. 0.79. What is the ratio of the Secondary income (in US$) of St. Kitts and Nevis in 2010 to that in 2013?
Provide a succinct answer. 0.66. What is the ratio of the Secondary income (in US$) in Vanuatu in 2010 to that in 2013?
Provide a succinct answer. 0.98. What is the ratio of the Secondary income (in US$) of Marshall Islands in 2011 to that in 2012?
Ensure brevity in your answer.  0.95. What is the ratio of the Secondary income (in US$) in St. Kitts and Nevis in 2011 to that in 2012?
Make the answer very short. 0.77. What is the ratio of the Secondary income (in US$) in Vanuatu in 2011 to that in 2012?
Make the answer very short. 0.59. What is the ratio of the Secondary income (in US$) of Marshall Islands in 2011 to that in 2013?
Your response must be concise. 0.89. What is the ratio of the Secondary income (in US$) in St. Kitts and Nevis in 2011 to that in 2013?
Your response must be concise. 0.74. What is the ratio of the Secondary income (in US$) in Vanuatu in 2011 to that in 2013?
Your response must be concise. 0.38. What is the ratio of the Secondary income (in US$) of Marshall Islands in 2012 to that in 2013?
Make the answer very short. 0.94. What is the ratio of the Secondary income (in US$) in St. Kitts and Nevis in 2012 to that in 2013?
Your answer should be compact. 0.96. What is the ratio of the Secondary income (in US$) in Vanuatu in 2012 to that in 2013?
Your answer should be compact. 0.64. What is the difference between the highest and the second highest Secondary income (in US$) of Marshall Islands?
Offer a terse response. 4.19e+05. What is the difference between the highest and the second highest Secondary income (in US$) of St. Kitts and Nevis?
Offer a terse response. 7.90e+05. What is the difference between the highest and the second highest Secondary income (in US$) of Vanuatu?
Provide a succinct answer. 1.48e+06. What is the difference between the highest and the lowest Secondary income (in US$) of Marshall Islands?
Keep it short and to the point. 3.02e+06. What is the difference between the highest and the lowest Secondary income (in US$) in St. Kitts and Nevis?
Give a very brief answer. 1.08e+07. What is the difference between the highest and the lowest Secondary income (in US$) in Vanuatu?
Make the answer very short. 3.38e+06. 